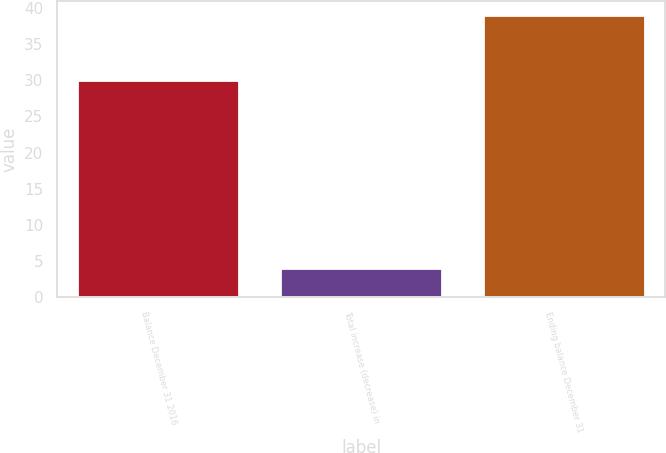Convert chart. <chart><loc_0><loc_0><loc_500><loc_500><bar_chart><fcel>Balance December 31 2016<fcel>Total increase (decrease) in<fcel>Ending balance December 31<nl><fcel>30<fcel>4<fcel>39<nl></chart> 